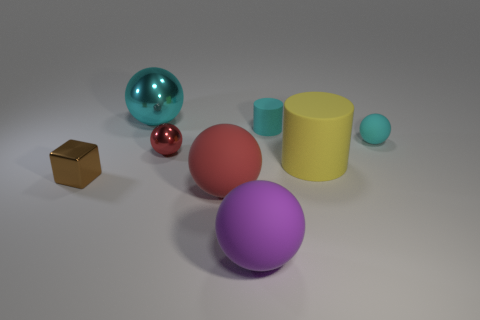There is a purple sphere that is the same size as the yellow matte object; what is its material?
Provide a short and direct response. Rubber. There is a brown shiny object that is to the left of the rubber ball in front of the matte thing to the left of the large purple matte thing; what is its size?
Your answer should be very brief. Small. There is a matte object that is left of the purple rubber ball; is it the same color as the shiny sphere that is in front of the big cyan metallic ball?
Your answer should be compact. Yes. How many gray objects are big objects or small shiny objects?
Your answer should be very brief. 0. How many purple cylinders are the same size as the purple thing?
Keep it short and to the point. 0. Are the red object behind the big yellow rubber object and the big yellow thing made of the same material?
Keep it short and to the point. No. There is a tiny thing to the right of the small cyan cylinder; is there a large red rubber ball that is behind it?
Provide a succinct answer. No. What material is the big cyan object that is the same shape as the large purple rubber thing?
Give a very brief answer. Metal. Are there more small brown cubes that are behind the tiny metallic block than yellow cylinders behind the large cyan sphere?
Your answer should be very brief. No. There is a big object that is the same material as the small red thing; what shape is it?
Offer a very short reply. Sphere. 